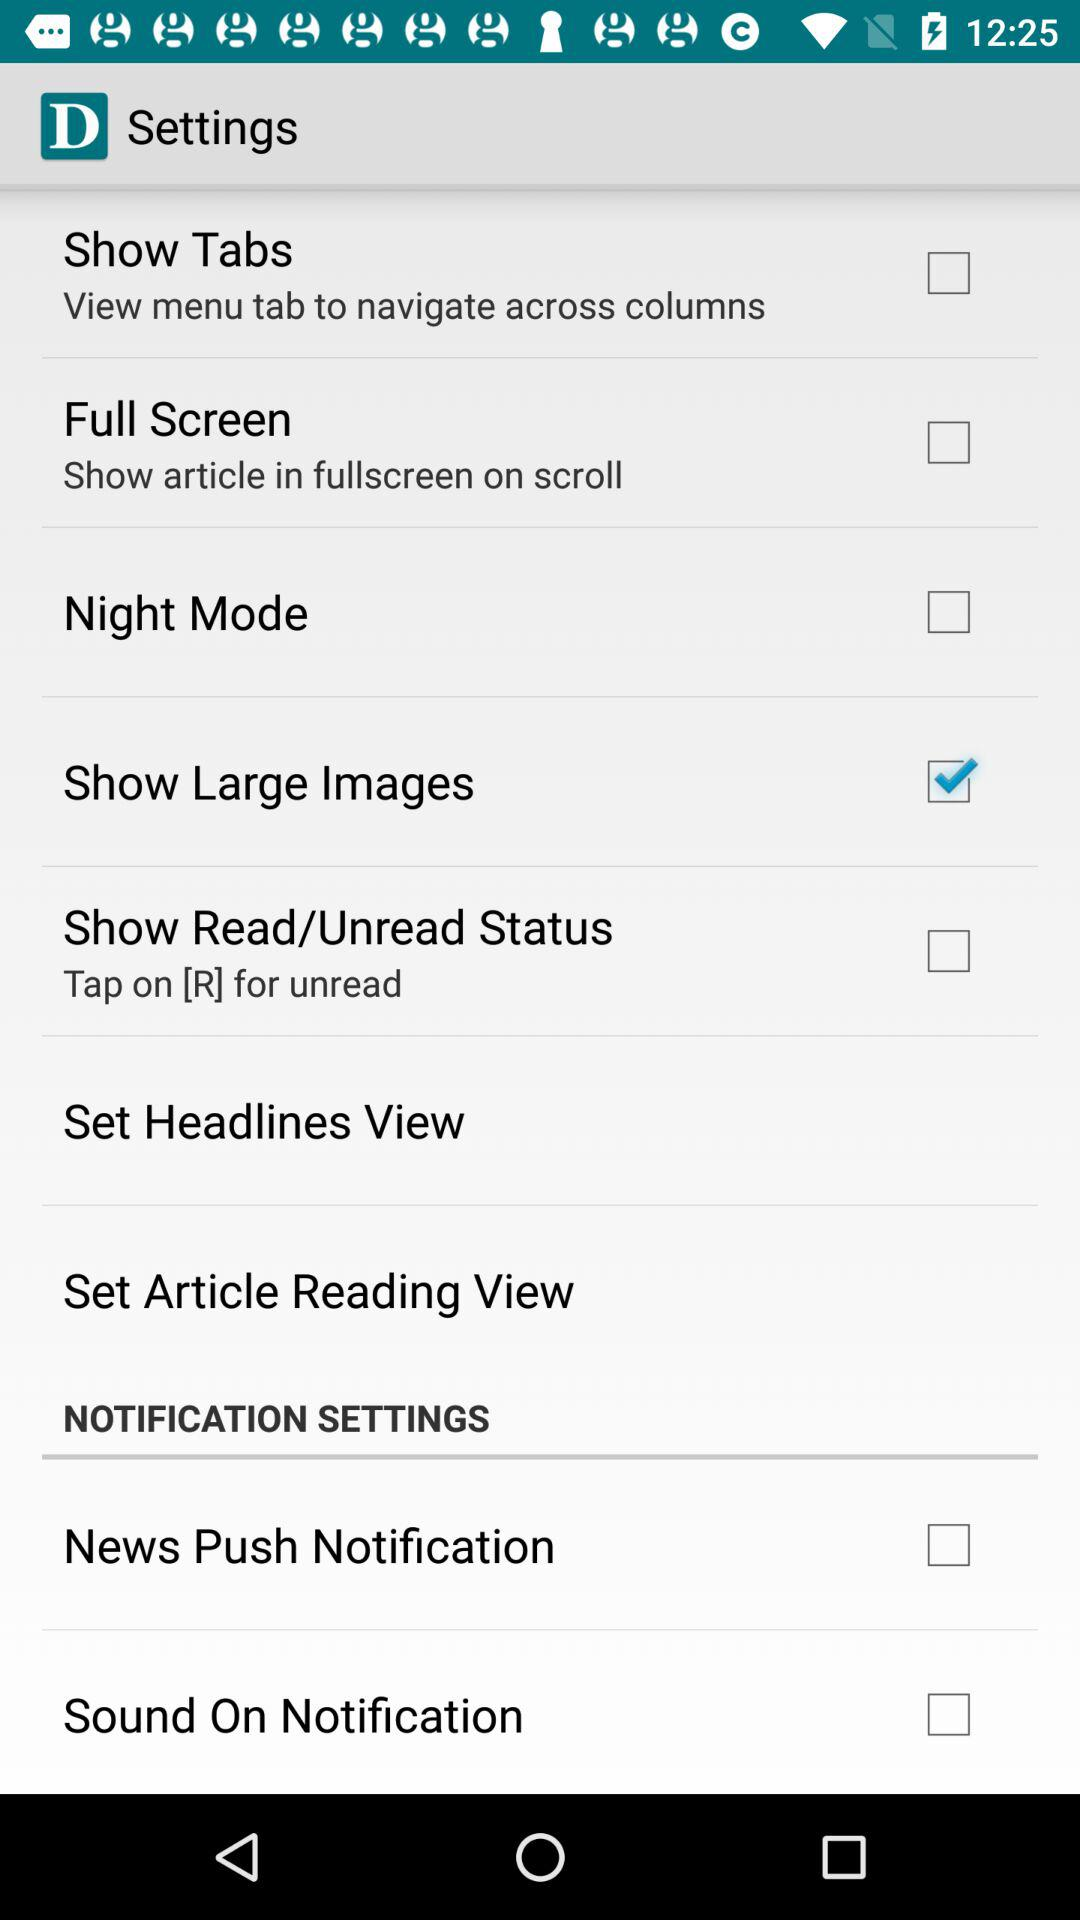What is the status of "Show Large Images"? The status is "on". 